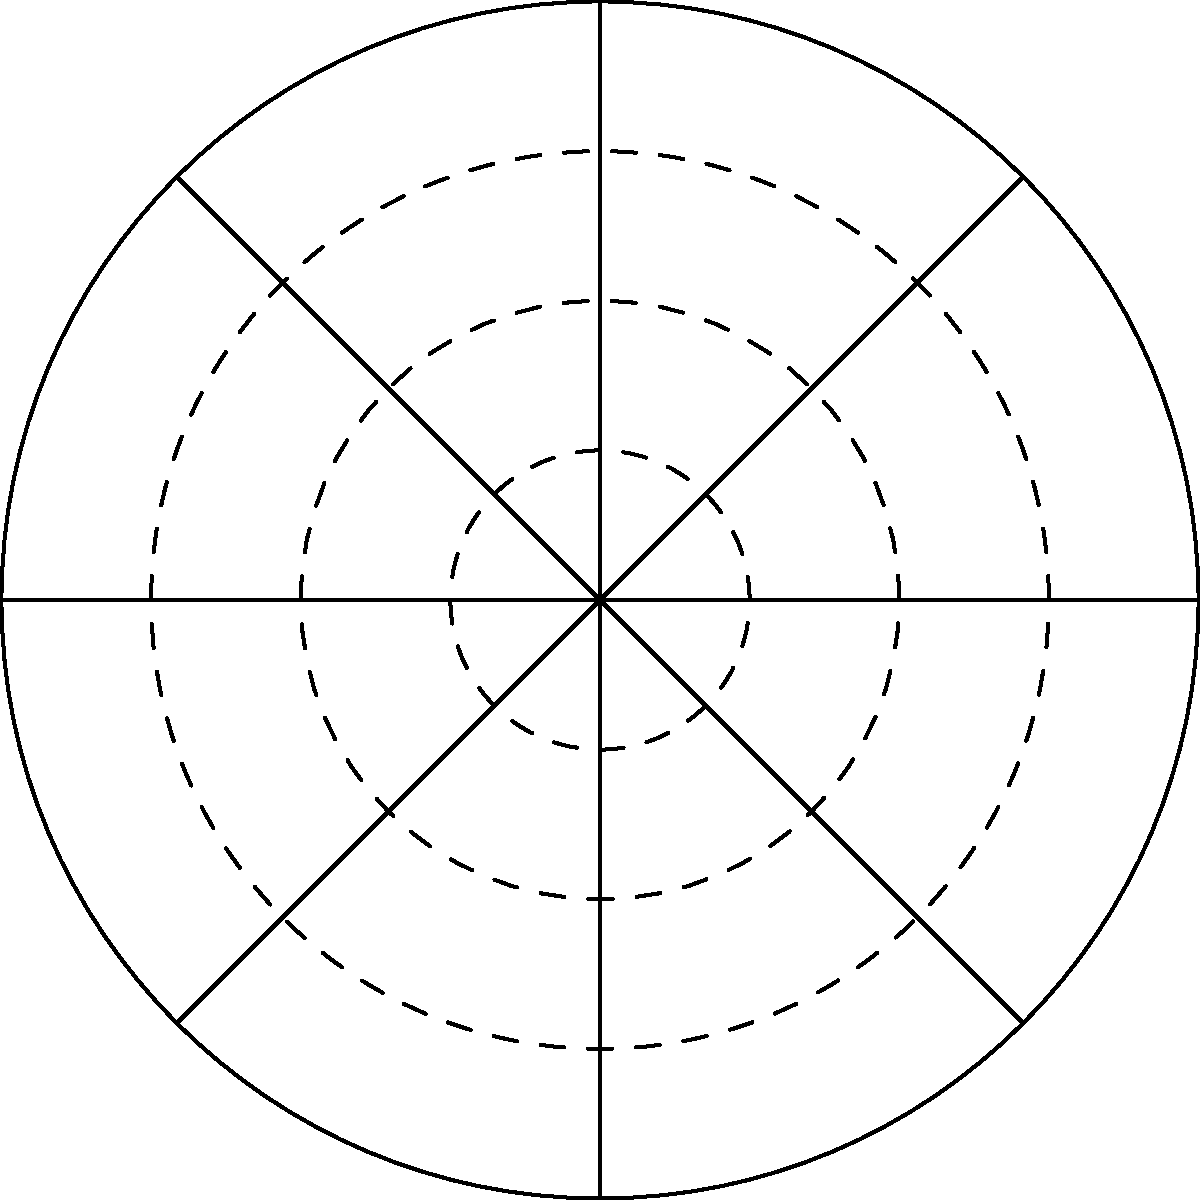During a severe weather event in Rockwall County, the Emergency Management Office reported two significant wind direction changes. The initial wind direction was 45° (red arrow), and it later shifted to 225° (blue arrow). If the wind speed remained constant at 50 mph, calculate the net displacement of an air particle after 2 hours of travel under these conditions. Assume the wind direction change occurred exactly halfway through the 2-hour period. To solve this problem, we'll follow these steps:

1) First, calculate the distance traveled in each direction:
   Time in each direction = 1 hour
   Distance = Speed × Time
   Distance = 50 mph × 1 hour = 50 miles in each direction

2) Convert the angles to radians:
   $45° = \frac{\pi}{4}$ radians
   $225° = \frac{5\pi}{4}$ radians

3) Calculate the x and y components for each direction:
   First direction (45°):
   $x_1 = 50 \cos(\frac{\pi}{4}) = 50 \cdot \frac{\sqrt{2}}{2} \approx 35.36$ miles
   $y_1 = 50 \sin(\frac{\pi}{4}) = 50 \cdot \frac{\sqrt{2}}{2} \approx 35.36$ miles

   Second direction (225°):
   $x_2 = 50 \cos(\frac{5\pi}{4}) = -50 \cdot \frac{\sqrt{2}}{2} \approx -35.36$ miles
   $y_2 = 50 \sin(\frac{5\pi}{4}) = -50 \cdot \frac{\sqrt{2}}{2} \approx -35.36$ miles

4) Sum the x and y components to get the net displacement:
   $x_{net} = x_1 + x_2 = 35.36 + (-35.36) = 0$ miles
   $y_{net} = y_1 + y_2 = 35.36 + (-35.36) = 0$ miles

5) Calculate the magnitude of the net displacement:
   $\text{Net Displacement} = \sqrt{x_{net}^2 + y_{net}^2} = \sqrt{0^2 + 0^2} = 0$ miles

Therefore, the net displacement of the air particle after 2 hours is 0 miles.
Answer: 0 miles 